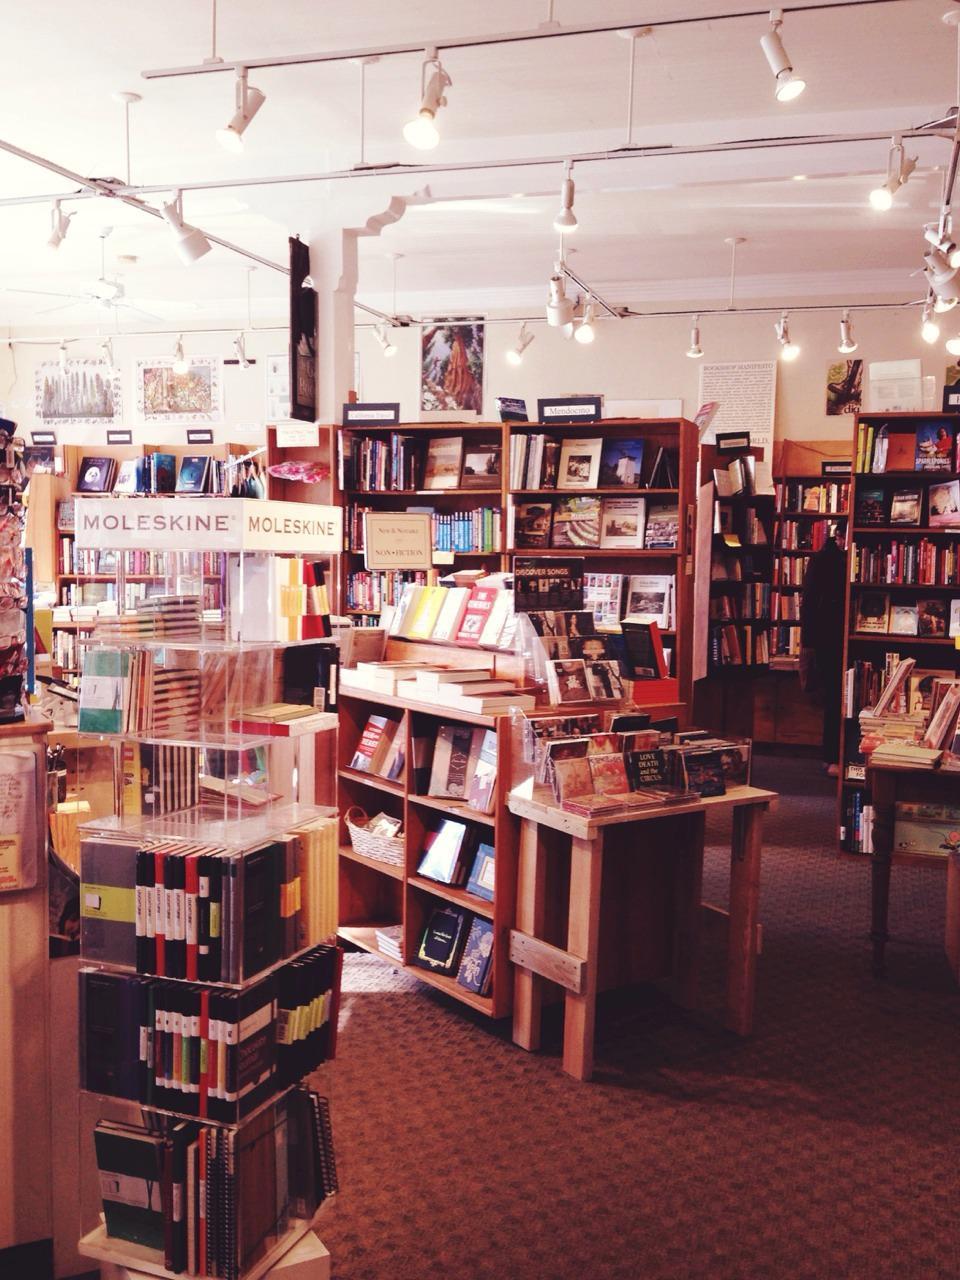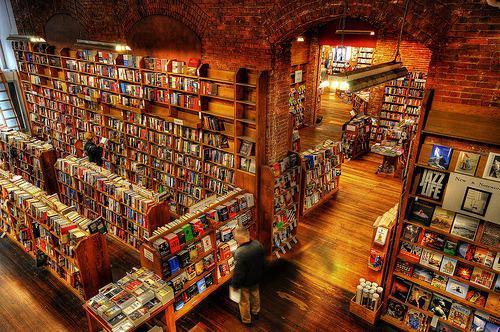The first image is the image on the left, the second image is the image on the right. Examine the images to the left and right. Is the description "To the left, there are some chairs that people can use for sitting." accurate? Answer yes or no. No. The first image is the image on the left, the second image is the image on the right. For the images displayed, is the sentence "There is only an image of the inside of a bookstore." factually correct? Answer yes or no. Yes. 